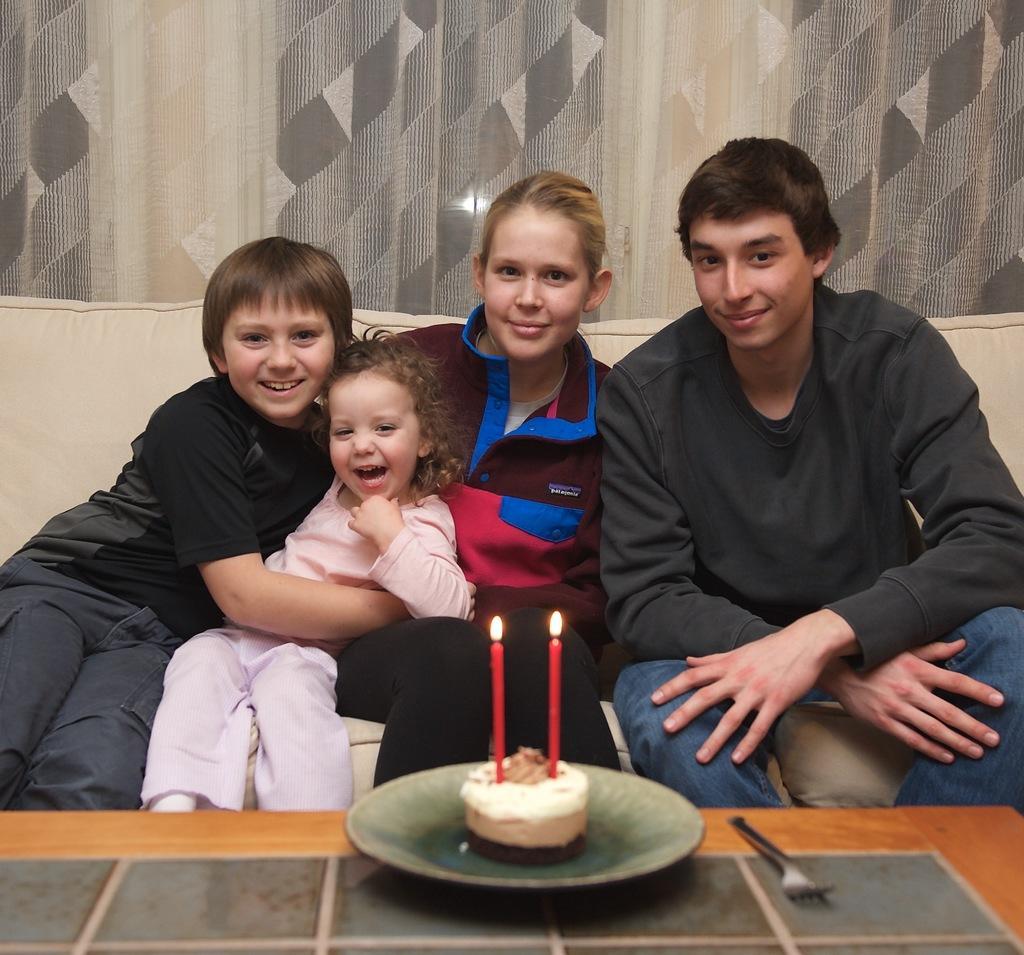Please provide a concise description of this image. In this picture, there is a table which is in yellow color, on that table there is a plate which is in green color, there is a cake in the plate, on the cake there are two candles which are in red color, in the background there are some people siting on the sofa which is in white color, there is a curtain which is in white and black color. 